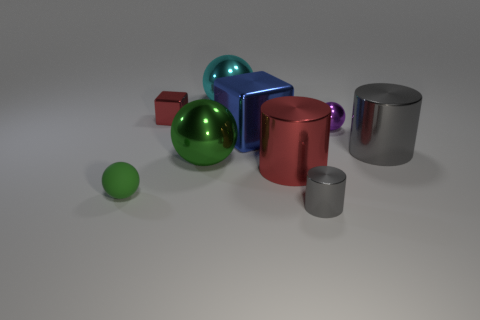Subtract all large shiny cylinders. How many cylinders are left? 1 Subtract all green spheres. How many gray cylinders are left? 2 Subtract 3 spheres. How many spheres are left? 1 Subtract all cylinders. How many objects are left? 6 Add 3 metal cylinders. How many metal cylinders are left? 6 Add 8 big gray cylinders. How many big gray cylinders exist? 9 Subtract all cyan spheres. How many spheres are left? 3 Subtract 0 cyan cylinders. How many objects are left? 9 Subtract all purple spheres. Subtract all red cylinders. How many spheres are left? 3 Subtract all tiny gray cylinders. Subtract all tiny gray cylinders. How many objects are left? 7 